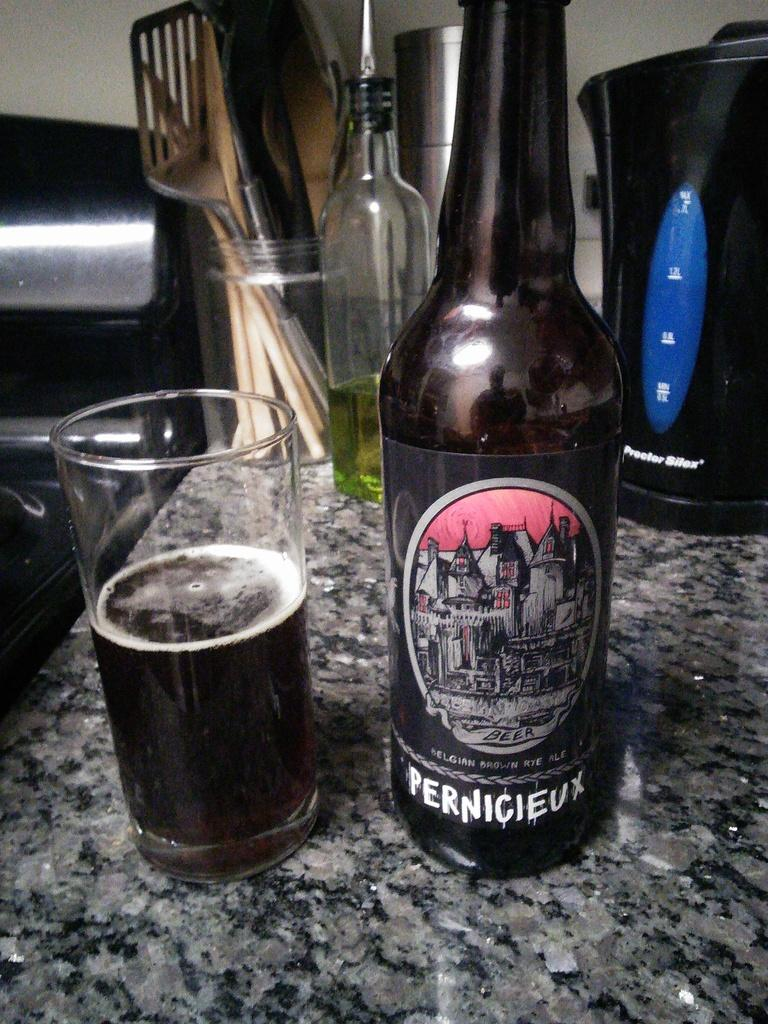<image>
Render a clear and concise summary of the photo. A bottle of Pernicieux sits on a stone counter along with a half-full glass. 